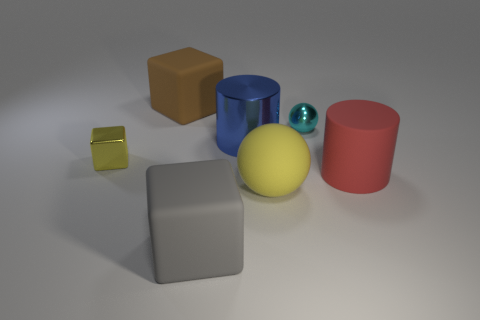Add 3 big cyan metal blocks. How many objects exist? 10 Add 3 large cylinders. How many large cylinders are left? 5 Add 4 small yellow metallic cylinders. How many small yellow metallic cylinders exist? 4 Subtract all cyan spheres. How many spheres are left? 1 Subtract all big rubber blocks. How many blocks are left? 1 Subtract 1 cyan spheres. How many objects are left? 6 Subtract all cylinders. How many objects are left? 5 Subtract 1 balls. How many balls are left? 1 Subtract all gray spheres. Subtract all gray cylinders. How many spheres are left? 2 Subtract all cyan balls. How many yellow blocks are left? 1 